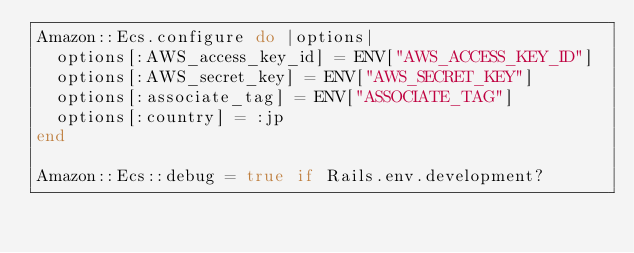Convert code to text. <code><loc_0><loc_0><loc_500><loc_500><_Ruby_>Amazon::Ecs.configure do |options|
  options[:AWS_access_key_id] = ENV["AWS_ACCESS_KEY_ID"]
  options[:AWS_secret_key] = ENV["AWS_SECRET_KEY"]
  options[:associate_tag] = ENV["ASSOCIATE_TAG"]
  options[:country] = :jp
end

Amazon::Ecs::debug = true if Rails.env.development?
</code> 